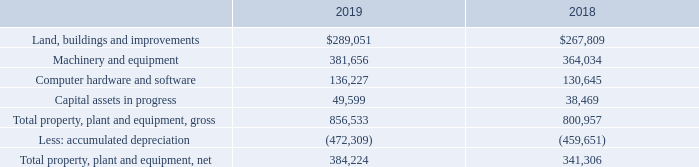3. Property, Plant and Equipment
Property, plant and equipment as of September 28, 2019 and September 29, 2018 consisted of the following (in thousands):
Which years does the table provide information for Property, plant and equipment? 2019, 2018. What was the amount of Land, buildings and improvements in 2018?
Answer scale should be: thousand. 267,809. What was the amount of Capital assets in progress in 2019?
Answer scale should be: thousand. 49,599. Which years did Machinery and equipment exceed $300,000 thousand? (2019:381,656),(2018:364,034)
Answer: 2019, 2018. What was the change in Computer hardware and software between 2018 and 2019?
Answer scale should be: thousand. 136,227-130,645
Answer: 5582. What was the percentage change in the Capital assets in progress between 2018 and 2019?
Answer scale should be: percent. (49,599-38,469)/38,469
Answer: 28.93. 